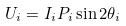Convert formula to latex. <formula><loc_0><loc_0><loc_500><loc_500>U _ { i } = I _ { i } P _ { i } \sin 2 \theta _ { i }</formula> 